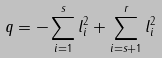Convert formula to latex. <formula><loc_0><loc_0><loc_500><loc_500>q = - \sum _ { i = 1 } ^ { s } l _ { i } ^ { 2 } + \sum _ { i = s + 1 } ^ { r } l _ { i } ^ { 2 }</formula> 